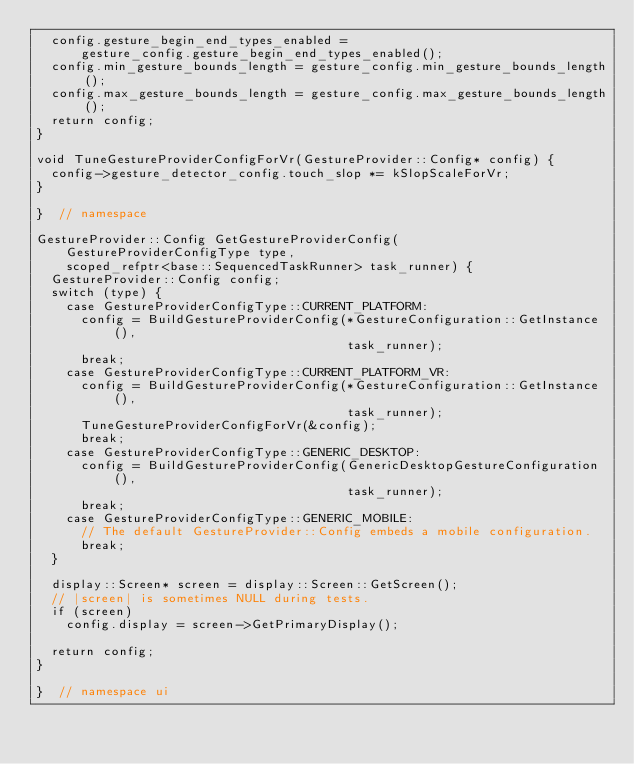Convert code to text. <code><loc_0><loc_0><loc_500><loc_500><_C++_>  config.gesture_begin_end_types_enabled =
      gesture_config.gesture_begin_end_types_enabled();
  config.min_gesture_bounds_length = gesture_config.min_gesture_bounds_length();
  config.max_gesture_bounds_length = gesture_config.max_gesture_bounds_length();
  return config;
}

void TuneGestureProviderConfigForVr(GestureProvider::Config* config) {
  config->gesture_detector_config.touch_slop *= kSlopScaleForVr;
}

}  // namespace

GestureProvider::Config GetGestureProviderConfig(
    GestureProviderConfigType type,
    scoped_refptr<base::SequencedTaskRunner> task_runner) {
  GestureProvider::Config config;
  switch (type) {
    case GestureProviderConfigType::CURRENT_PLATFORM:
      config = BuildGestureProviderConfig(*GestureConfiguration::GetInstance(),
                                          task_runner);
      break;
    case GestureProviderConfigType::CURRENT_PLATFORM_VR:
      config = BuildGestureProviderConfig(*GestureConfiguration::GetInstance(),
                                          task_runner);
      TuneGestureProviderConfigForVr(&config);
      break;
    case GestureProviderConfigType::GENERIC_DESKTOP:
      config = BuildGestureProviderConfig(GenericDesktopGestureConfiguration(),
                                          task_runner);
      break;
    case GestureProviderConfigType::GENERIC_MOBILE:
      // The default GestureProvider::Config embeds a mobile configuration.
      break;
  }

  display::Screen* screen = display::Screen::GetScreen();
  // |screen| is sometimes NULL during tests.
  if (screen)
    config.display = screen->GetPrimaryDisplay();

  return config;
}

}  // namespace ui
</code> 